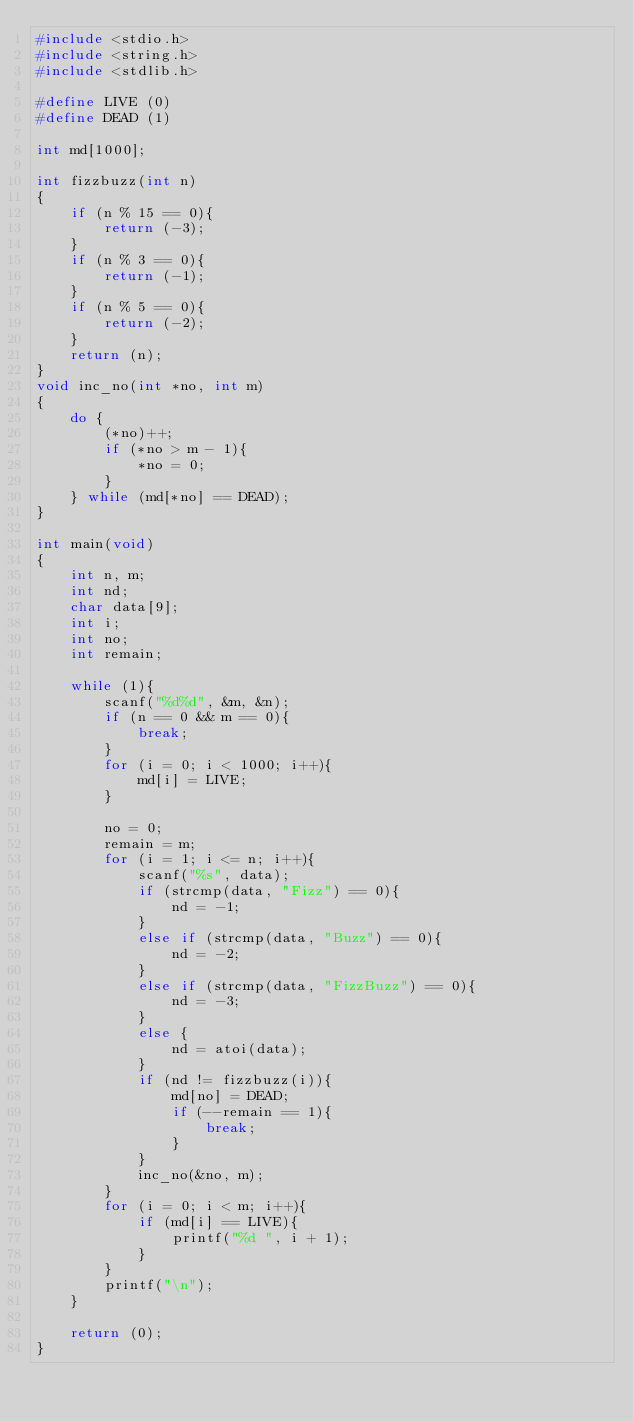Convert code to text. <code><loc_0><loc_0><loc_500><loc_500><_C_>#include <stdio.h>
#include <string.h>
#include <stdlib.h>

#define LIVE (0)
#define DEAD (1)

int md[1000];

int fizzbuzz(int n)
{
	if (n % 15 == 0){
		return (-3);
	}
	if (n % 3 == 0){
		return (-1);
	}
	if (n % 5 == 0){
		return (-2);
	}
	return (n);
}
void inc_no(int *no, int m)
{
	do {
		(*no)++;
		if (*no > m - 1){
			*no = 0;
		}
	} while (md[*no] == DEAD);
}

int main(void)
{
	int n, m;
	int nd;
	char data[9];
	int i;
	int no;
    int remain;
	
	while (1){
		scanf("%d%d", &m, &n);
		if (n == 0 && m == 0){
			break;
		}
		for (i = 0; i < 1000; i++){
			md[i] = LIVE;
		}

		no = 0;
        remain = m;
		for (i = 1; i <= n; i++){
			scanf("%s", data);
			if (strcmp(data, "Fizz") == 0){
				nd = -1;
			}
			else if (strcmp(data, "Buzz") == 0){
				nd = -2;
			}
			else if (strcmp(data, "FizzBuzz") == 0){
				nd = -3;
			}
			else {
				nd = atoi(data);
			}
			if (nd != fizzbuzz(i)){
				md[no] = DEAD;
                if (--remain == 1){
                    break;
                }
			}
			inc_no(&no, m);
		}
		for (i = 0; i < m; i++){
			if (md[i] == LIVE){
				printf("%d ", i + 1);
			}
		}
		printf("\n");
	}

	return (0);
}</code> 